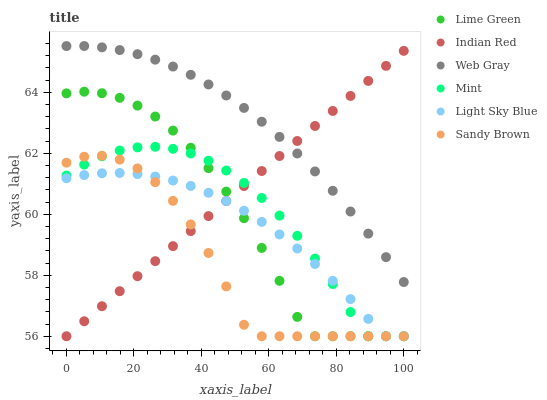Does Sandy Brown have the minimum area under the curve?
Answer yes or no. Yes. Does Web Gray have the maximum area under the curve?
Answer yes or no. Yes. Does Lime Green have the minimum area under the curve?
Answer yes or no. No. Does Lime Green have the maximum area under the curve?
Answer yes or no. No. Is Indian Red the smoothest?
Answer yes or no. Yes. Is Sandy Brown the roughest?
Answer yes or no. Yes. Is Lime Green the smoothest?
Answer yes or no. No. Is Lime Green the roughest?
Answer yes or no. No. Does Sandy Brown have the lowest value?
Answer yes or no. Yes. Does Web Gray have the highest value?
Answer yes or no. Yes. Does Sandy Brown have the highest value?
Answer yes or no. No. Is Light Sky Blue less than Web Gray?
Answer yes or no. Yes. Is Web Gray greater than Light Sky Blue?
Answer yes or no. Yes. Does Mint intersect Indian Red?
Answer yes or no. Yes. Is Mint less than Indian Red?
Answer yes or no. No. Is Mint greater than Indian Red?
Answer yes or no. No. Does Light Sky Blue intersect Web Gray?
Answer yes or no. No. 